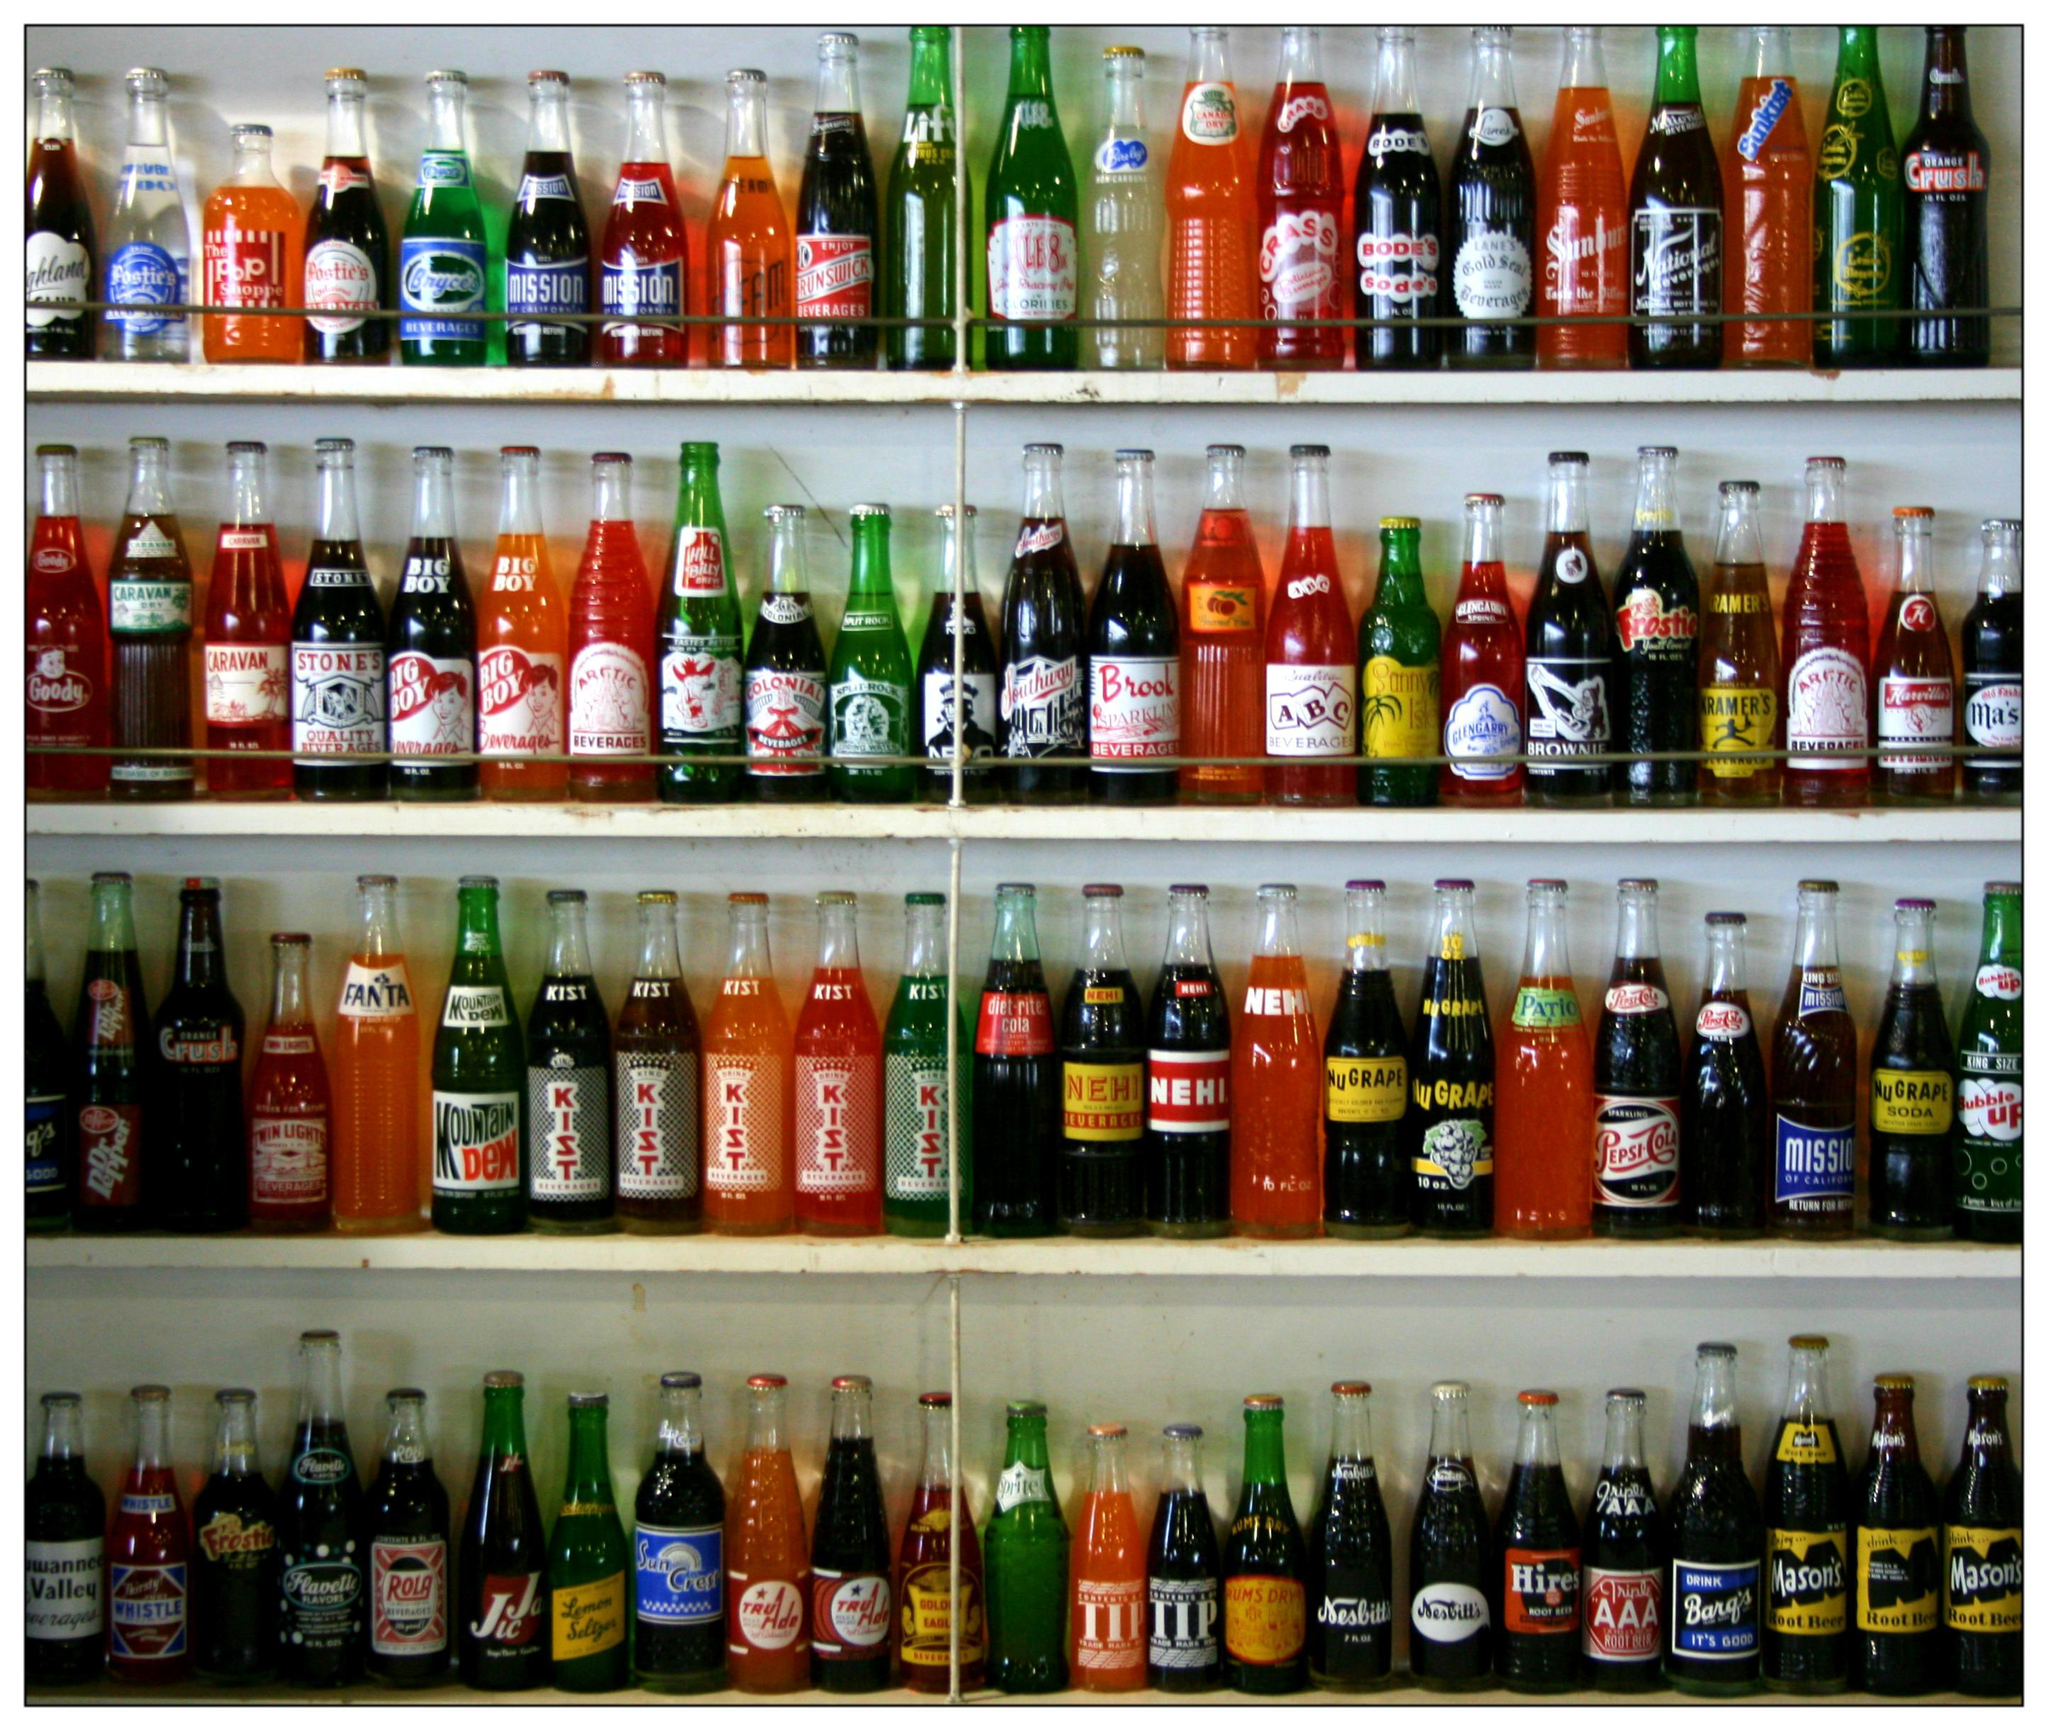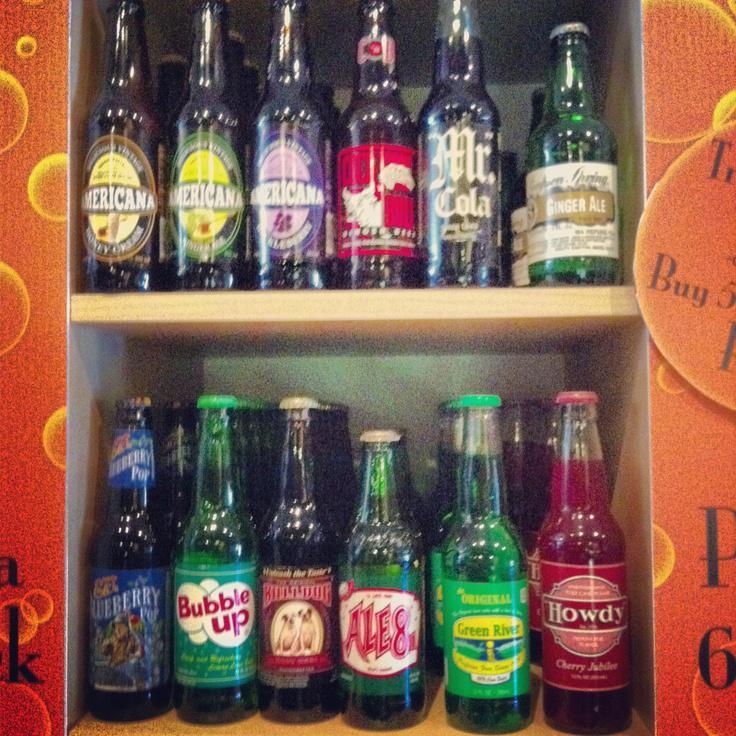The first image is the image on the left, the second image is the image on the right. For the images shown, is this caption "There are no glass bottles in the right image." true? Answer yes or no. No. The first image is the image on the left, the second image is the image on the right. Analyze the images presented: Is the assertion "There are lots of American brand, plastic soda bottles." valid? Answer yes or no. No. 